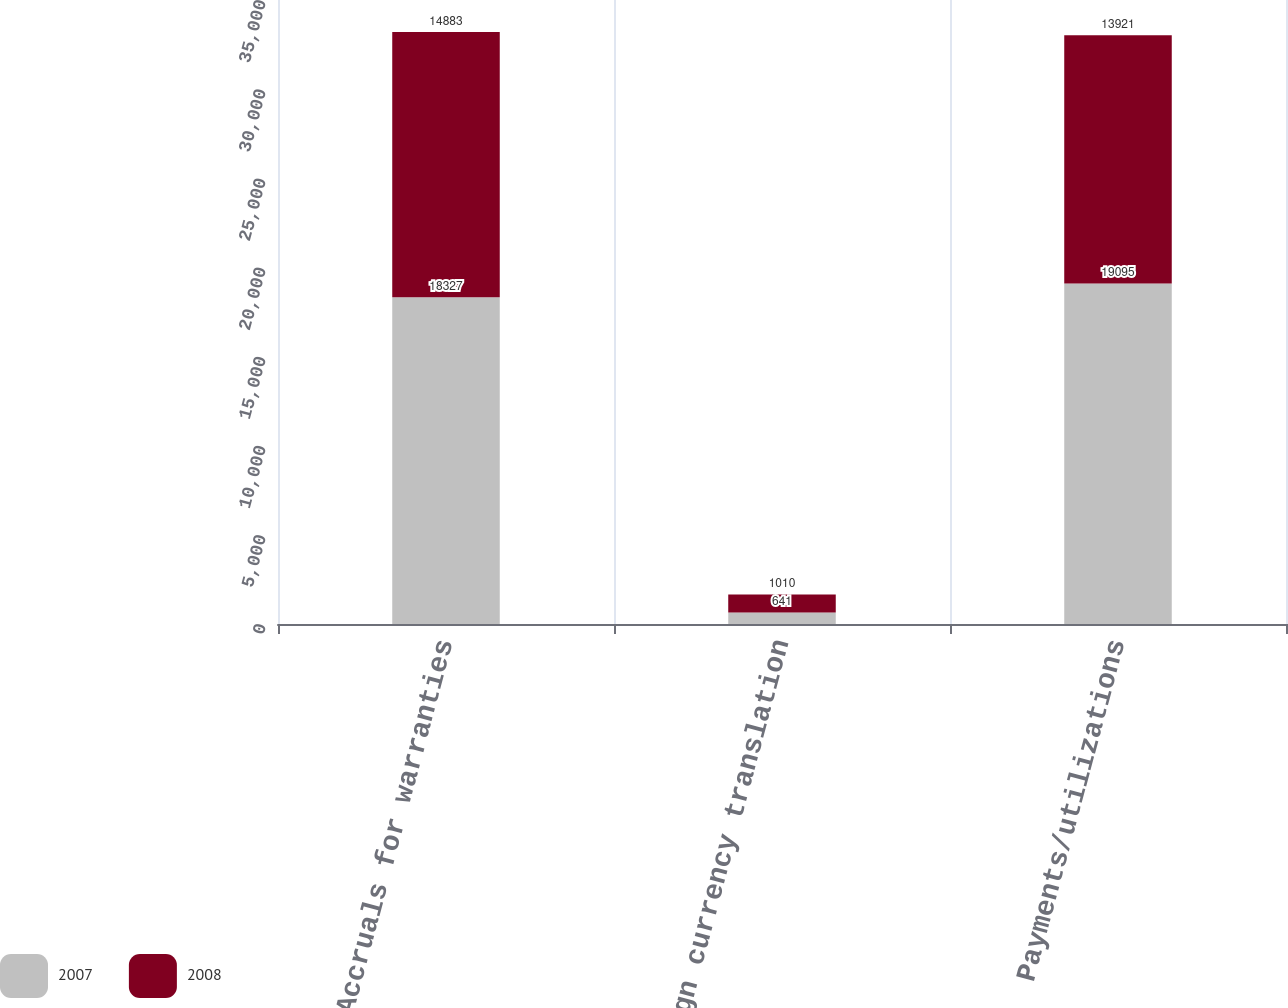Convert chart. <chart><loc_0><loc_0><loc_500><loc_500><stacked_bar_chart><ecel><fcel>Accruals for warranties<fcel>Foreign currency translation<fcel>Payments/utilizations<nl><fcel>2007<fcel>18327<fcel>641<fcel>19095<nl><fcel>2008<fcel>14883<fcel>1010<fcel>13921<nl></chart> 